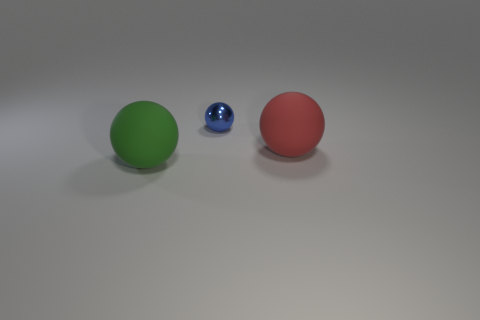Is the number of big balls that are behind the big green matte object greater than the number of big metal cylinders?
Provide a succinct answer. Yes. Do the shiny thing and the big object that is in front of the big red ball have the same shape?
Provide a short and direct response. Yes. How many small objects are either red metallic cylinders or red balls?
Provide a succinct answer. 0. The rubber ball that is behind the big sphere that is to the left of the blue shiny ball is what color?
Your answer should be very brief. Red. Are the big red object and the tiny ball behind the big red matte thing made of the same material?
Your answer should be very brief. No. There is a green object that is on the left side of the tiny metallic thing; what is it made of?
Provide a short and direct response. Rubber. Are there the same number of red rubber objects that are to the right of the big red thing and tiny red balls?
Make the answer very short. Yes. Are there any other things that are the same size as the blue metal sphere?
Keep it short and to the point. No. There is a large object on the left side of the matte ball to the right of the green rubber thing; what is it made of?
Offer a terse response. Rubber. There is a thing that is to the right of the green sphere and in front of the blue shiny sphere; what is its shape?
Keep it short and to the point. Sphere. 